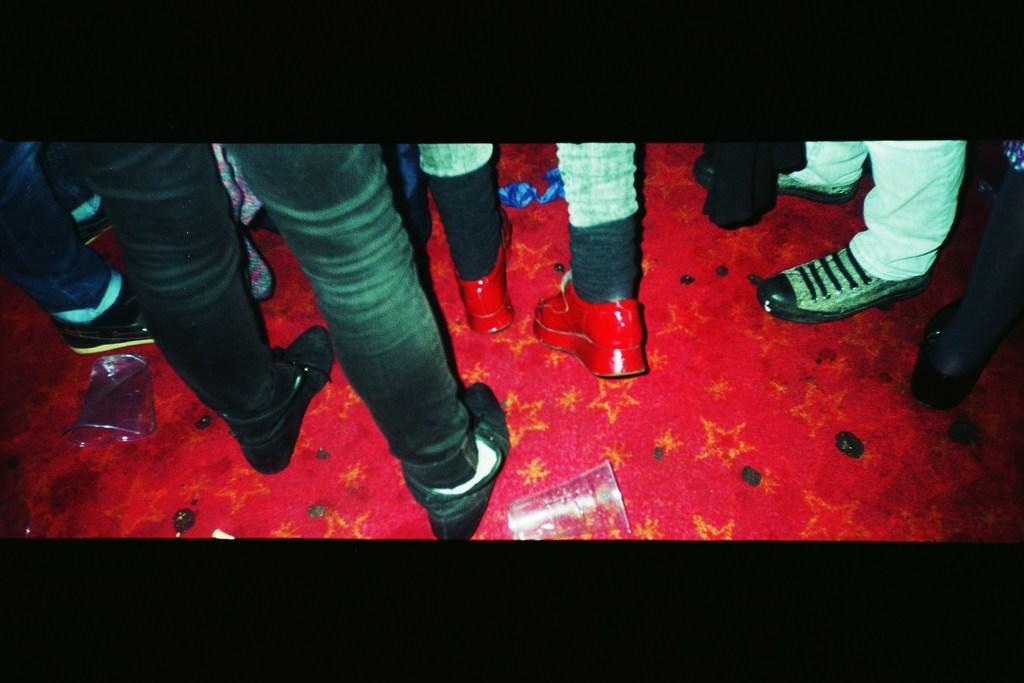Could you give a brief overview of what you see in this image? In this picture I can observe some people standing on the floor. All of them are wearing shoes. They are standing on the red color floor. I can observe glasses on the floor. 